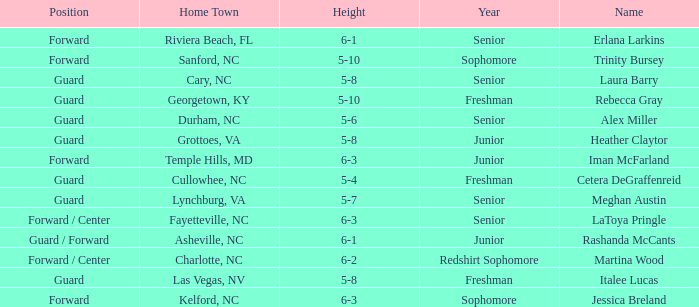In what year of school is the player from Fayetteville, NC? Senior. 